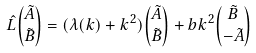Convert formula to latex. <formula><loc_0><loc_0><loc_500><loc_500>\hat { L } { \tilde { A } \choose \tilde { B } } = ( \lambda ( k ) + k ^ { 2 } ) { \tilde { A } \choose \tilde { B } } + b k ^ { 2 } { \tilde { B } \choose - \tilde { A } }</formula> 